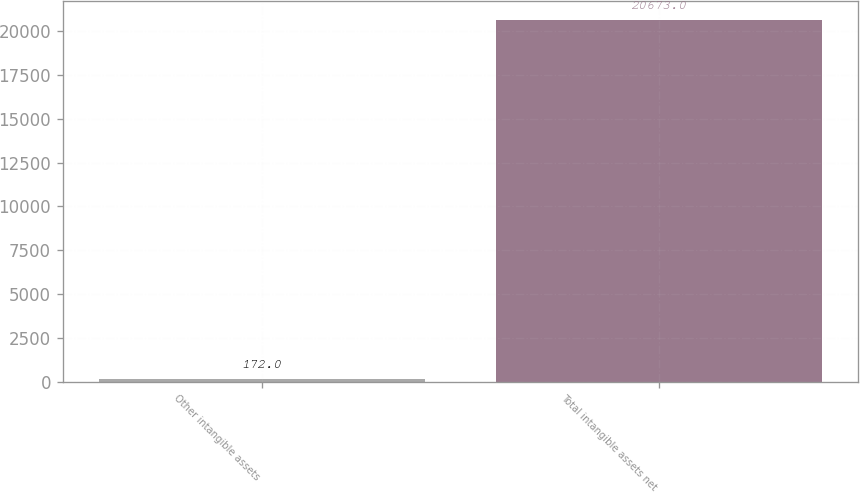Convert chart to OTSL. <chart><loc_0><loc_0><loc_500><loc_500><bar_chart><fcel>Other intangible assets<fcel>Total intangible assets net<nl><fcel>172<fcel>20673<nl></chart> 